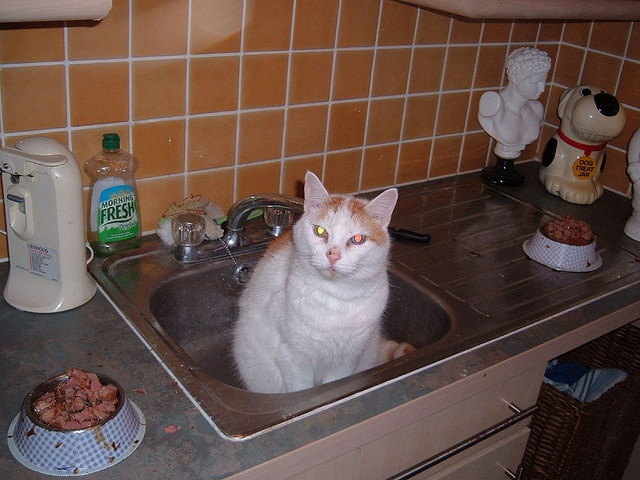Describe the objects in this image and their specific colors. I can see cat in gray, darkgray, and lightgray tones, sink in gray and black tones, bowl in gray, maroon, black, and brown tones, and bottle in gray, black, brown, and darkgray tones in this image. 